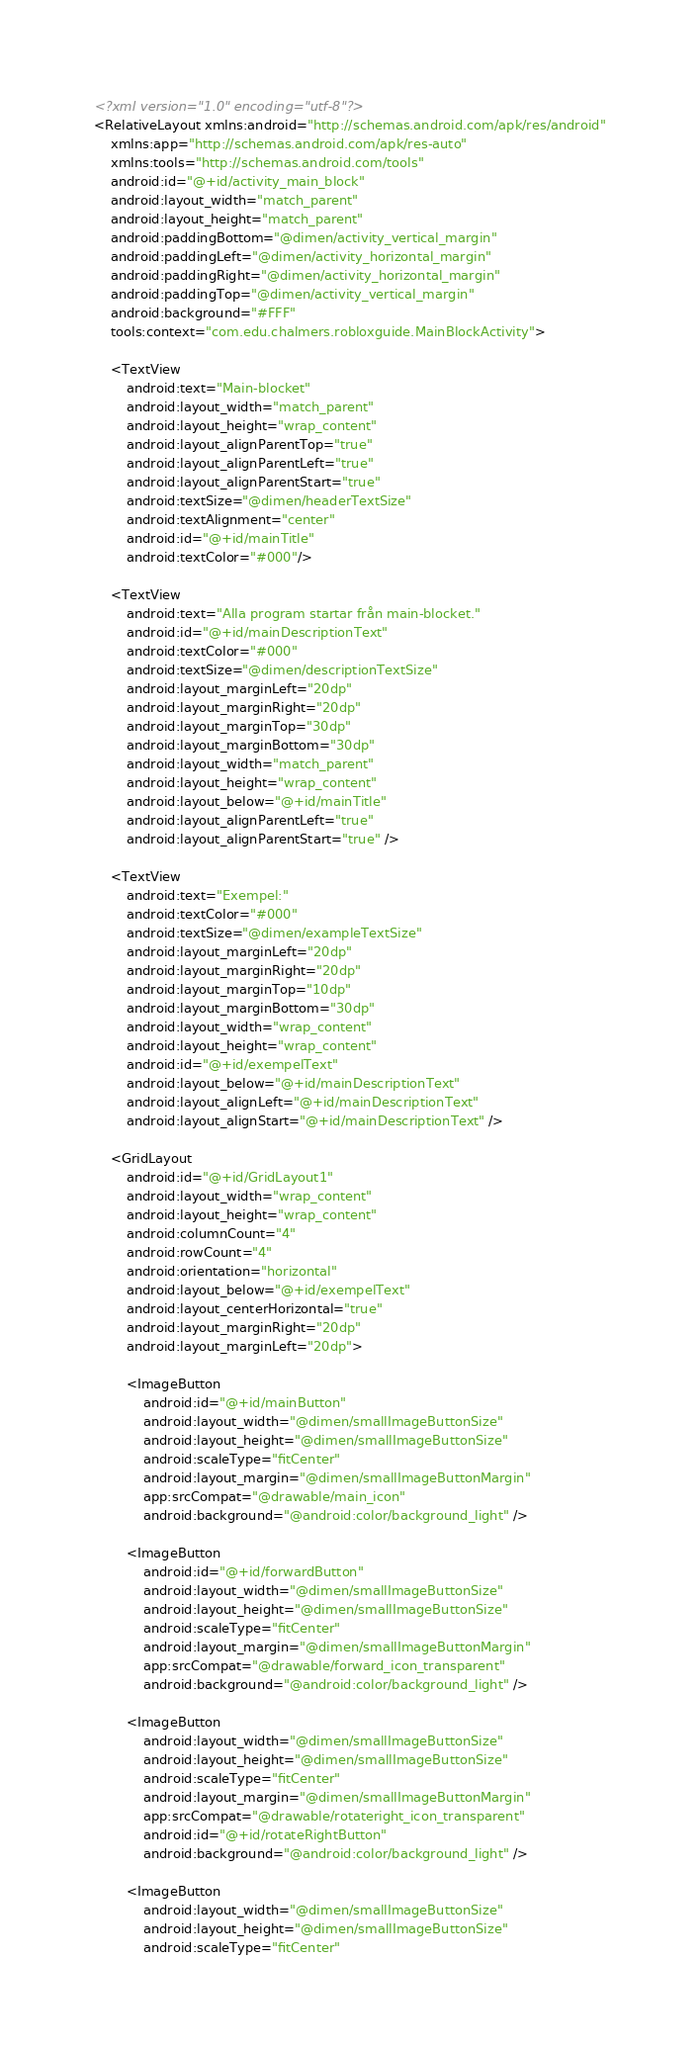Convert code to text. <code><loc_0><loc_0><loc_500><loc_500><_XML_><?xml version="1.0" encoding="utf-8"?>
<RelativeLayout xmlns:android="http://schemas.android.com/apk/res/android"
    xmlns:app="http://schemas.android.com/apk/res-auto"
    xmlns:tools="http://schemas.android.com/tools"
    android:id="@+id/activity_main_block"
    android:layout_width="match_parent"
    android:layout_height="match_parent"
    android:paddingBottom="@dimen/activity_vertical_margin"
    android:paddingLeft="@dimen/activity_horizontal_margin"
    android:paddingRight="@dimen/activity_horizontal_margin"
    android:paddingTop="@dimen/activity_vertical_margin"
    android:background="#FFF"
    tools:context="com.edu.chalmers.robloxguide.MainBlockActivity">

    <TextView
        android:text="Main-blocket"
        android:layout_width="match_parent"
        android:layout_height="wrap_content"
        android:layout_alignParentTop="true"
        android:layout_alignParentLeft="true"
        android:layout_alignParentStart="true"
        android:textSize="@dimen/headerTextSize"
        android:textAlignment="center"
        android:id="@+id/mainTitle"
        android:textColor="#000"/>

    <TextView
        android:text="Alla program startar från main-blocket."
        android:id="@+id/mainDescriptionText"
        android:textColor="#000"
        android:textSize="@dimen/descriptionTextSize"
        android:layout_marginLeft="20dp"
        android:layout_marginRight="20dp"
        android:layout_marginTop="30dp"
        android:layout_marginBottom="30dp"
        android:layout_width="match_parent"
        android:layout_height="wrap_content"
        android:layout_below="@+id/mainTitle"
        android:layout_alignParentLeft="true"
        android:layout_alignParentStart="true" />

    <TextView
        android:text="Exempel:"
        android:textColor="#000"
        android:textSize="@dimen/exampleTextSize"
        android:layout_marginLeft="20dp"
        android:layout_marginRight="20dp"
        android:layout_marginTop="10dp"
        android:layout_marginBottom="30dp"
        android:layout_width="wrap_content"
        android:layout_height="wrap_content"
        android:id="@+id/exempelText"
        android:layout_below="@+id/mainDescriptionText"
        android:layout_alignLeft="@+id/mainDescriptionText"
        android:layout_alignStart="@+id/mainDescriptionText" />

    <GridLayout
        android:id="@+id/GridLayout1"
        android:layout_width="wrap_content"
        android:layout_height="wrap_content"
        android:columnCount="4"
        android:rowCount="4"
        android:orientation="horizontal"
        android:layout_below="@+id/exempelText"
        android:layout_centerHorizontal="true"
        android:layout_marginRight="20dp"
        android:layout_marginLeft="20dp">

        <ImageButton
            android:id="@+id/mainButton"
            android:layout_width="@dimen/smallImageButtonSize"
            android:layout_height="@dimen/smallImageButtonSize"
            android:scaleType="fitCenter"
            android:layout_margin="@dimen/smallImageButtonMargin"
            app:srcCompat="@drawable/main_icon"
            android:background="@android:color/background_light" />

        <ImageButton
            android:id="@+id/forwardButton"
            android:layout_width="@dimen/smallImageButtonSize"
            android:layout_height="@dimen/smallImageButtonSize"
            android:scaleType="fitCenter"
            android:layout_margin="@dimen/smallImageButtonMargin"
            app:srcCompat="@drawable/forward_icon_transparent"
            android:background="@android:color/background_light" />

        <ImageButton
            android:layout_width="@dimen/smallImageButtonSize"
            android:layout_height="@dimen/smallImageButtonSize"
            android:scaleType="fitCenter"
            android:layout_margin="@dimen/smallImageButtonMargin"
            app:srcCompat="@drawable/rotateright_icon_transparent"
            android:id="@+id/rotateRightButton"
            android:background="@android:color/background_light" />

        <ImageButton
            android:layout_width="@dimen/smallImageButtonSize"
            android:layout_height="@dimen/smallImageButtonSize"
            android:scaleType="fitCenter"</code> 